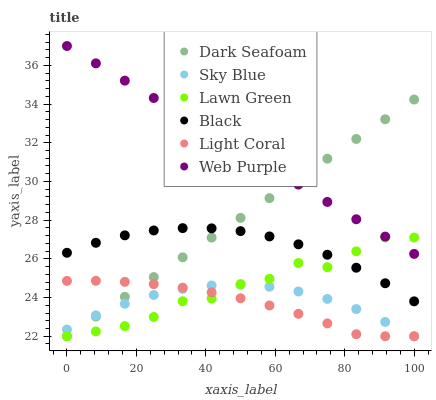Does Light Coral have the minimum area under the curve?
Answer yes or no. Yes. Does Web Purple have the maximum area under the curve?
Answer yes or no. Yes. Does Web Purple have the minimum area under the curve?
Answer yes or no. No. Does Light Coral have the maximum area under the curve?
Answer yes or no. No. Is Dark Seafoam the smoothest?
Answer yes or no. Yes. Is Lawn Green the roughest?
Answer yes or no. Yes. Is Web Purple the smoothest?
Answer yes or no. No. Is Web Purple the roughest?
Answer yes or no. No. Does Lawn Green have the lowest value?
Answer yes or no. Yes. Does Web Purple have the lowest value?
Answer yes or no. No. Does Web Purple have the highest value?
Answer yes or no. Yes. Does Light Coral have the highest value?
Answer yes or no. No. Is Sky Blue less than Web Purple?
Answer yes or no. Yes. Is Web Purple greater than Light Coral?
Answer yes or no. Yes. Does Dark Seafoam intersect Sky Blue?
Answer yes or no. Yes. Is Dark Seafoam less than Sky Blue?
Answer yes or no. No. Is Dark Seafoam greater than Sky Blue?
Answer yes or no. No. Does Sky Blue intersect Web Purple?
Answer yes or no. No. 